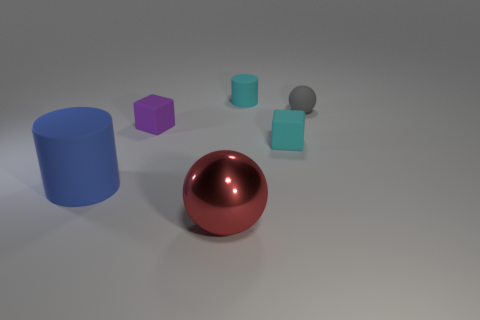There is a object that is the same color as the small cylinder; what shape is it?
Keep it short and to the point. Cube. What number of other rubber things are the same size as the gray rubber thing?
Provide a short and direct response. 3. The large shiny object has what color?
Make the answer very short. Red. There is a small matte cylinder; does it have the same color as the matte block to the right of the tiny matte cylinder?
Keep it short and to the point. Yes. The blue object that is made of the same material as the gray thing is what size?
Make the answer very short. Large. Is there a tiny thing that has the same color as the tiny cylinder?
Provide a short and direct response. Yes. How many things are tiny purple rubber cubes to the left of the small ball or cyan rubber objects?
Offer a very short reply. 3. Is the material of the blue thing the same as the purple thing that is behind the blue rubber thing?
Your response must be concise. Yes. What is the size of the object that is the same color as the small matte cylinder?
Your answer should be very brief. Small. Are there any cyan cylinders that have the same material as the purple block?
Offer a terse response. Yes. 